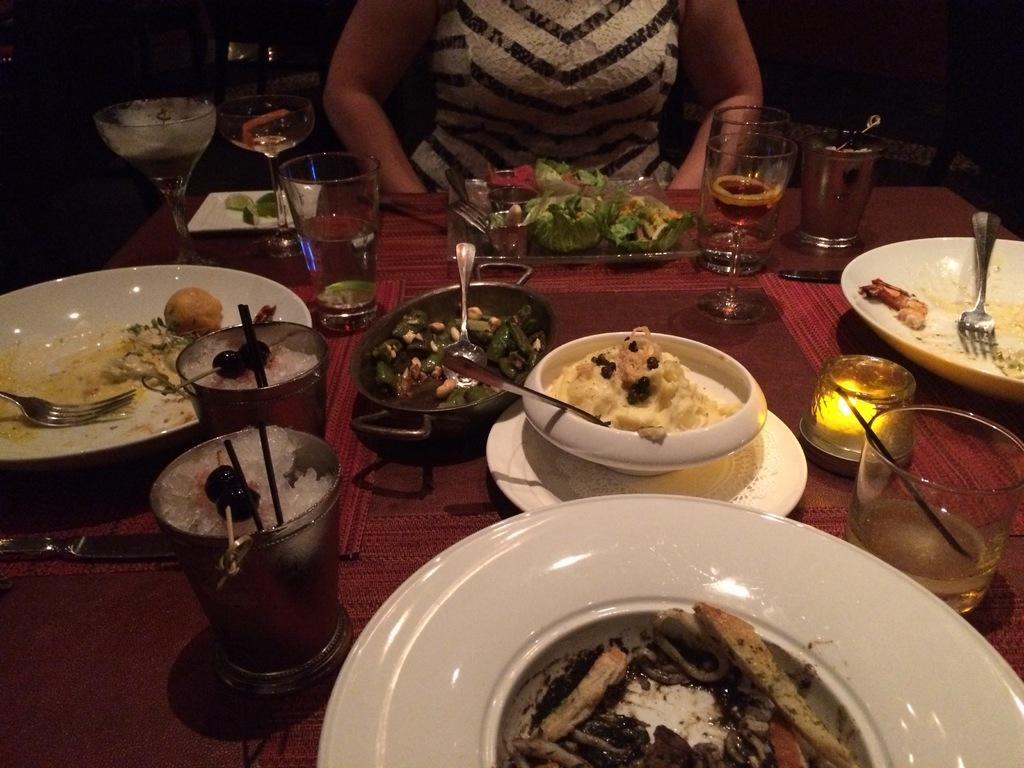What is the person in the image doing? The person is sitting near the table. What can be seen on the table in the image? There are plates, cups, glasses, spoons, food items, and other objects on the table. What might the person be using to eat or drink? The person might be using the spoons, cups, and plates on the table. What is the lighting condition in the image? The background of the image is dark. What type of army is depicted in the image? There is no army present in the image; it features a person sitting near a table with various objects on it. How does the person in the image make sense of the situation? The image does not provide information about the person's thoughts or understanding of the situation. 